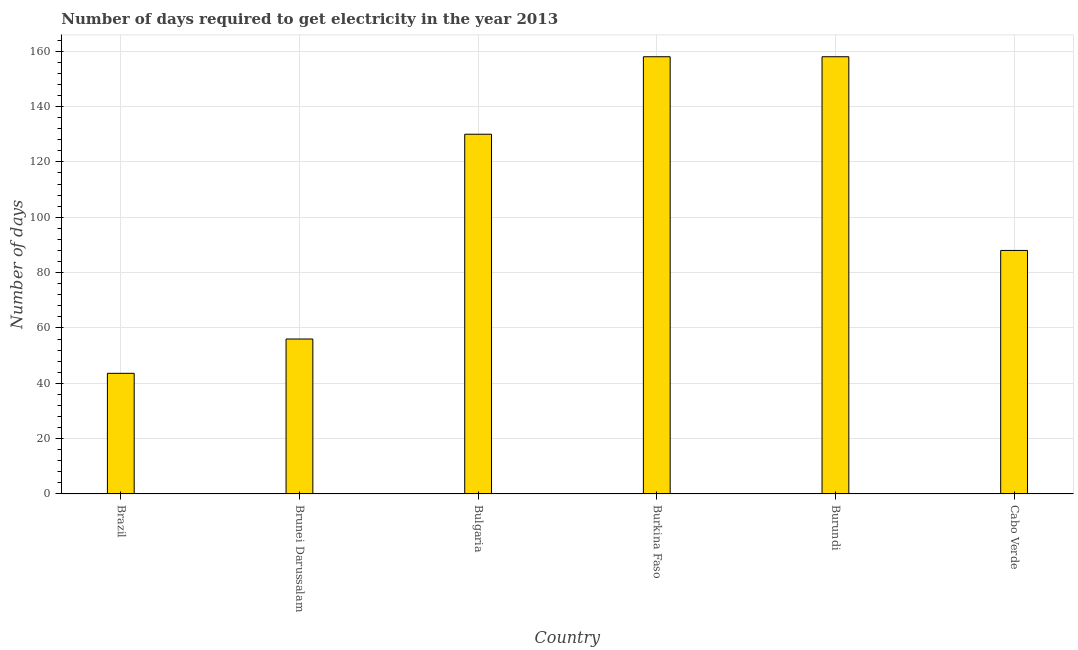Does the graph contain any zero values?
Provide a succinct answer. No. Does the graph contain grids?
Your response must be concise. Yes. What is the title of the graph?
Your answer should be very brief. Number of days required to get electricity in the year 2013. What is the label or title of the X-axis?
Make the answer very short. Country. What is the label or title of the Y-axis?
Your response must be concise. Number of days. What is the time to get electricity in Brazil?
Your answer should be very brief. 43.6. Across all countries, what is the maximum time to get electricity?
Keep it short and to the point. 158. Across all countries, what is the minimum time to get electricity?
Offer a terse response. 43.6. In which country was the time to get electricity maximum?
Give a very brief answer. Burkina Faso. What is the sum of the time to get electricity?
Give a very brief answer. 633.6. What is the difference between the time to get electricity in Brunei Darussalam and Burkina Faso?
Offer a very short reply. -102. What is the average time to get electricity per country?
Your answer should be very brief. 105.6. What is the median time to get electricity?
Make the answer very short. 109. What is the ratio of the time to get electricity in Brunei Darussalam to that in Bulgaria?
Provide a short and direct response. 0.43. What is the difference between the highest and the second highest time to get electricity?
Your answer should be very brief. 0. Is the sum of the time to get electricity in Bulgaria and Cabo Verde greater than the maximum time to get electricity across all countries?
Offer a terse response. Yes. What is the difference between the highest and the lowest time to get electricity?
Ensure brevity in your answer.  114.4. Are all the bars in the graph horizontal?
Offer a very short reply. No. What is the difference between two consecutive major ticks on the Y-axis?
Ensure brevity in your answer.  20. Are the values on the major ticks of Y-axis written in scientific E-notation?
Offer a very short reply. No. What is the Number of days of Brazil?
Ensure brevity in your answer.  43.6. What is the Number of days of Bulgaria?
Make the answer very short. 130. What is the Number of days in Burkina Faso?
Offer a very short reply. 158. What is the Number of days in Burundi?
Your answer should be compact. 158. What is the Number of days of Cabo Verde?
Provide a succinct answer. 88. What is the difference between the Number of days in Brazil and Bulgaria?
Make the answer very short. -86.4. What is the difference between the Number of days in Brazil and Burkina Faso?
Your response must be concise. -114.4. What is the difference between the Number of days in Brazil and Burundi?
Offer a very short reply. -114.4. What is the difference between the Number of days in Brazil and Cabo Verde?
Offer a very short reply. -44.4. What is the difference between the Number of days in Brunei Darussalam and Bulgaria?
Your answer should be compact. -74. What is the difference between the Number of days in Brunei Darussalam and Burkina Faso?
Make the answer very short. -102. What is the difference between the Number of days in Brunei Darussalam and Burundi?
Your response must be concise. -102. What is the difference between the Number of days in Brunei Darussalam and Cabo Verde?
Your answer should be very brief. -32. What is the difference between the Number of days in Bulgaria and Burkina Faso?
Provide a short and direct response. -28. What is the difference between the Number of days in Bulgaria and Burundi?
Your response must be concise. -28. What is the difference between the Number of days in Bulgaria and Cabo Verde?
Make the answer very short. 42. What is the difference between the Number of days in Burkina Faso and Burundi?
Give a very brief answer. 0. What is the difference between the Number of days in Burkina Faso and Cabo Verde?
Keep it short and to the point. 70. What is the ratio of the Number of days in Brazil to that in Brunei Darussalam?
Offer a very short reply. 0.78. What is the ratio of the Number of days in Brazil to that in Bulgaria?
Your answer should be compact. 0.34. What is the ratio of the Number of days in Brazil to that in Burkina Faso?
Ensure brevity in your answer.  0.28. What is the ratio of the Number of days in Brazil to that in Burundi?
Keep it short and to the point. 0.28. What is the ratio of the Number of days in Brazil to that in Cabo Verde?
Ensure brevity in your answer.  0.49. What is the ratio of the Number of days in Brunei Darussalam to that in Bulgaria?
Provide a short and direct response. 0.43. What is the ratio of the Number of days in Brunei Darussalam to that in Burkina Faso?
Your answer should be compact. 0.35. What is the ratio of the Number of days in Brunei Darussalam to that in Burundi?
Provide a succinct answer. 0.35. What is the ratio of the Number of days in Brunei Darussalam to that in Cabo Verde?
Offer a terse response. 0.64. What is the ratio of the Number of days in Bulgaria to that in Burkina Faso?
Keep it short and to the point. 0.82. What is the ratio of the Number of days in Bulgaria to that in Burundi?
Give a very brief answer. 0.82. What is the ratio of the Number of days in Bulgaria to that in Cabo Verde?
Provide a succinct answer. 1.48. What is the ratio of the Number of days in Burkina Faso to that in Burundi?
Offer a very short reply. 1. What is the ratio of the Number of days in Burkina Faso to that in Cabo Verde?
Give a very brief answer. 1.79. What is the ratio of the Number of days in Burundi to that in Cabo Verde?
Keep it short and to the point. 1.79. 